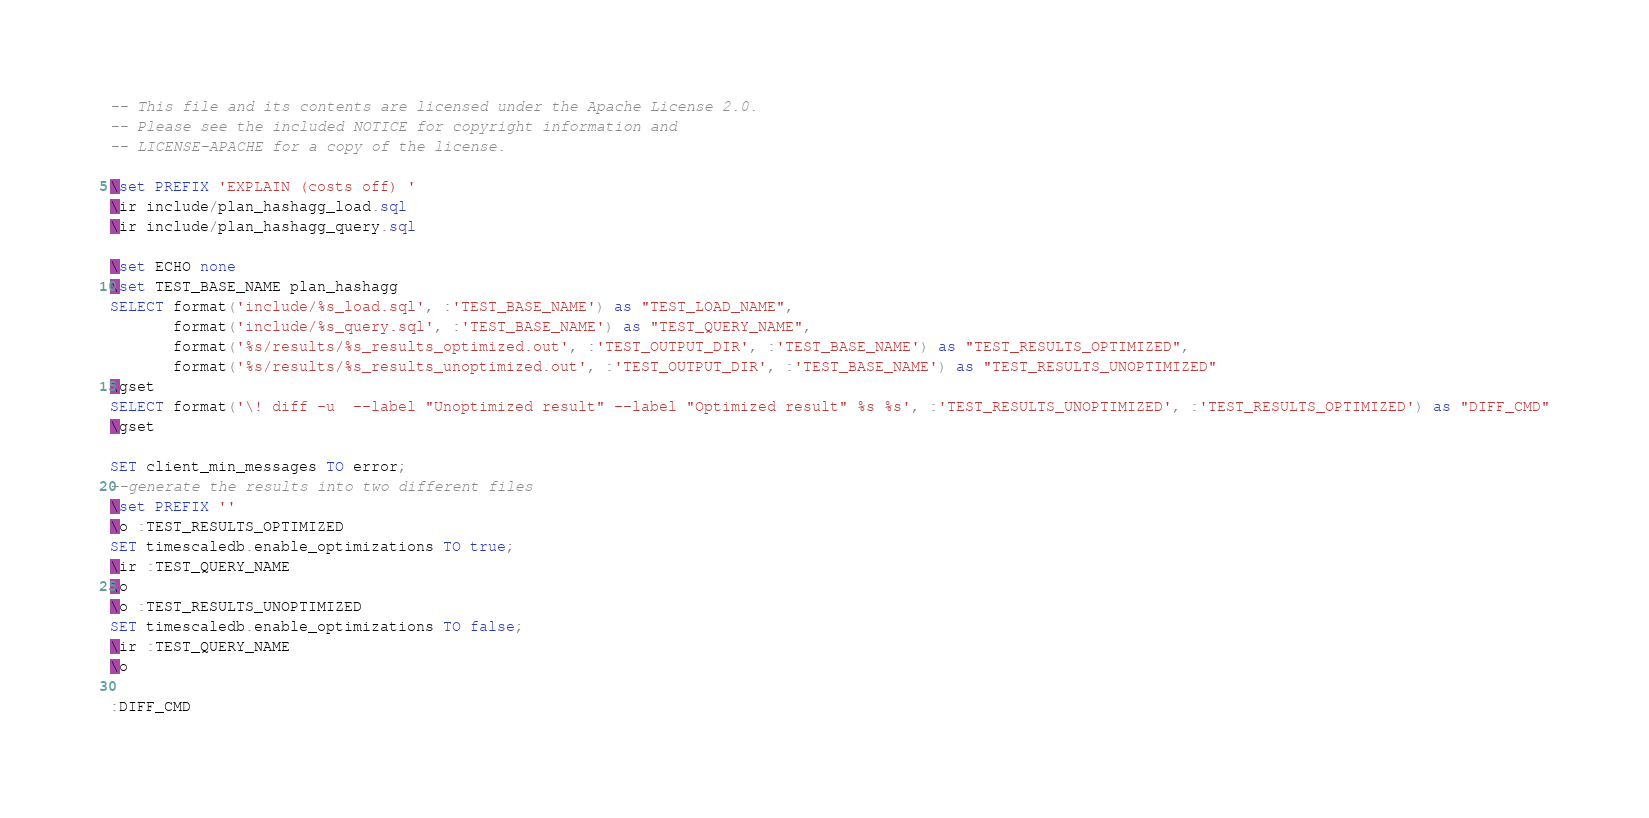Convert code to text. <code><loc_0><loc_0><loc_500><loc_500><_SQL_>-- This file and its contents are licensed under the Apache License 2.0.
-- Please see the included NOTICE for copyright information and
-- LICENSE-APACHE for a copy of the license.

\set PREFIX 'EXPLAIN (costs off) '
\ir include/plan_hashagg_load.sql
\ir include/plan_hashagg_query.sql

\set ECHO none
\set TEST_BASE_NAME plan_hashagg
SELECT format('include/%s_load.sql', :'TEST_BASE_NAME') as "TEST_LOAD_NAME",
       format('include/%s_query.sql', :'TEST_BASE_NAME') as "TEST_QUERY_NAME",
       format('%s/results/%s_results_optimized.out', :'TEST_OUTPUT_DIR', :'TEST_BASE_NAME') as "TEST_RESULTS_OPTIMIZED",
       format('%s/results/%s_results_unoptimized.out', :'TEST_OUTPUT_DIR', :'TEST_BASE_NAME') as "TEST_RESULTS_UNOPTIMIZED"
\gset
SELECT format('\! diff -u  --label "Unoptimized result" --label "Optimized result" %s %s', :'TEST_RESULTS_UNOPTIMIZED', :'TEST_RESULTS_OPTIMIZED') as "DIFF_CMD"
\gset

SET client_min_messages TO error;
--generate the results into two different files
\set PREFIX ''
\o :TEST_RESULTS_OPTIMIZED
SET timescaledb.enable_optimizations TO true;
\ir :TEST_QUERY_NAME
\o
\o :TEST_RESULTS_UNOPTIMIZED
SET timescaledb.enable_optimizations TO false;
\ir :TEST_QUERY_NAME
\o

:DIFF_CMD
</code> 